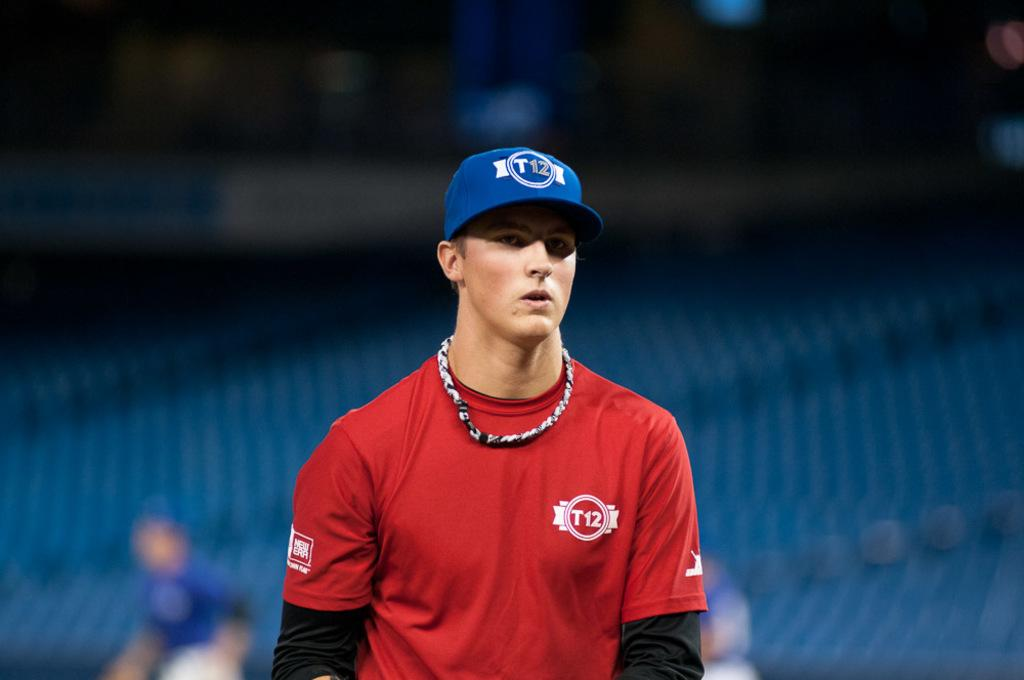<image>
Relay a brief, clear account of the picture shown. A male player with a blue baseball cap with the team T12 and a red shirt with the team T12. 